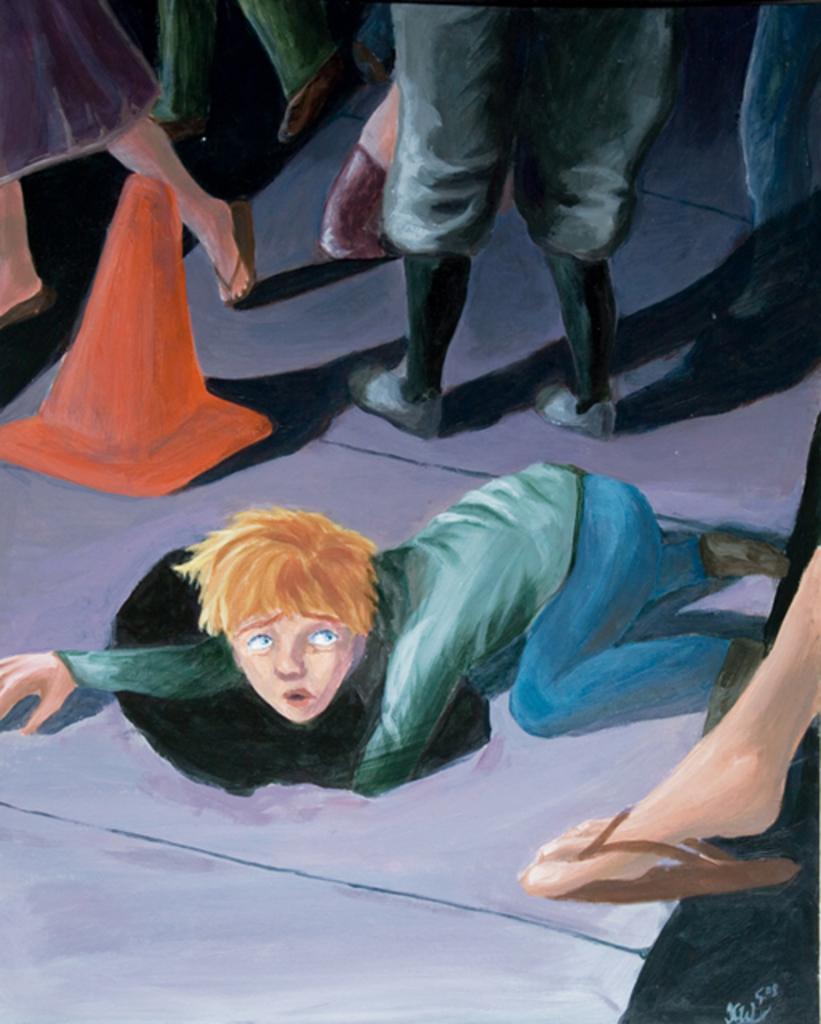Describe this image in one or two sentences. In the picture I can see a painting of a person lying on the ground, here I can see a person´s leg wearing footwear, I can see red color road cone and a few more people walking on the road. 